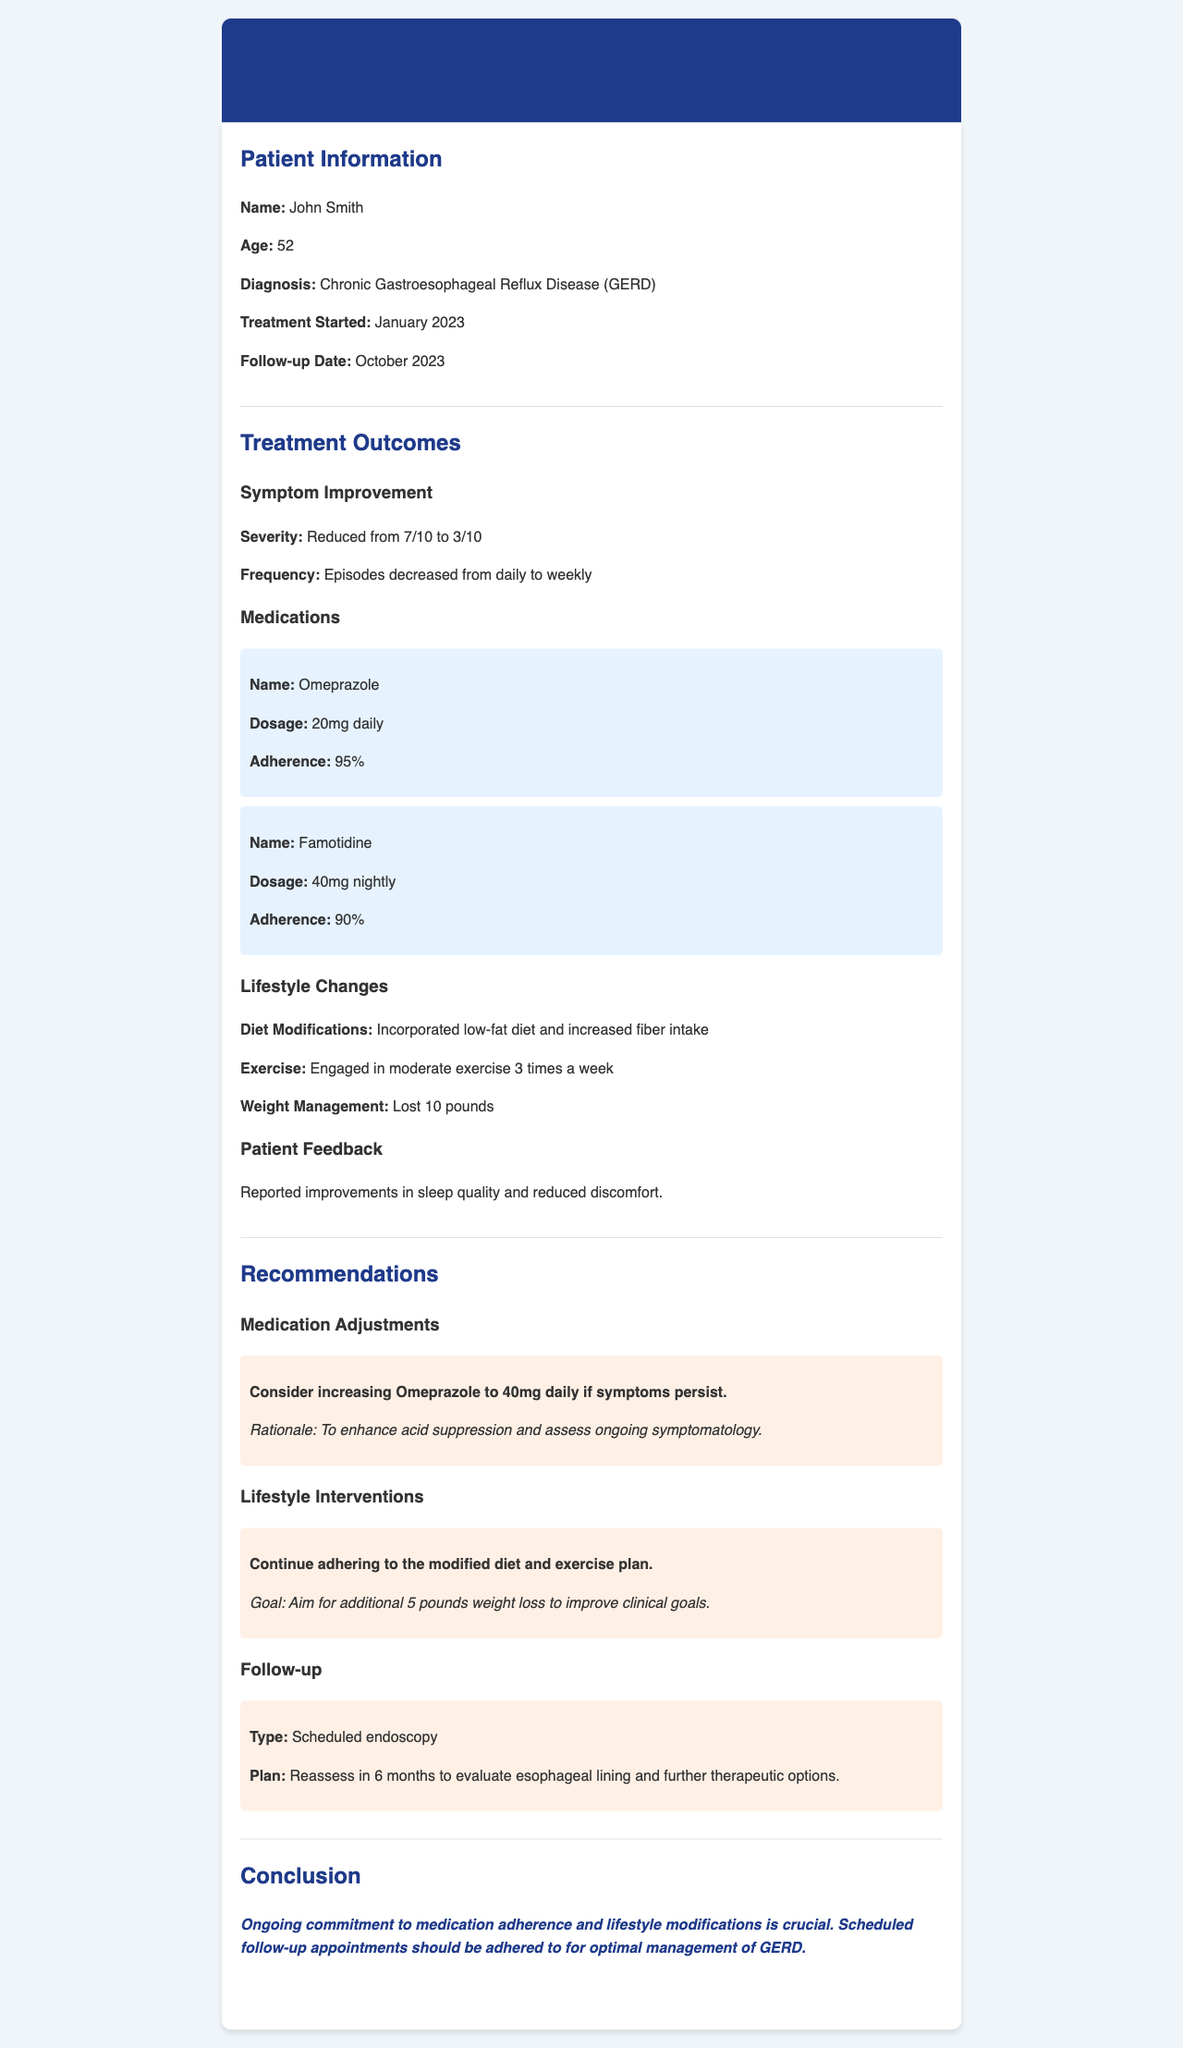What is the patient's name? The patient's name is provided in the Patient Information section of the report.
Answer: John Smith What is the patient's diagnosis? The diagnosis is clearly stated in the Patient Information section.
Answer: Chronic Gastroesophageal Reflux Disease (GERD) What was the patient's symptom severity before treatment? The severity before treatment is mentioned in the Treatment Outcomes section.
Answer: 7/10 What medication is being taken at night? The name of the nightly medication is found in the Treatments Outcomes section under Medications.
Answer: Famotidine What lifestyle change has the patient made regarding weight? The patient's weight management progress is documented in the Treatment Outcomes section.
Answer: Lost 10 pounds What is the recommended dose increase for Omeprazole if symptoms persist? The recommendation for medication adjustment can be found in the Recommendations section.
Answer: 40mg daily How often did the patient engage in exercise? The frequency of exercise is mentioned under Lifestyle Changes in the Treatment Outcomes section.
Answer: 3 times a week What is the goal for weight loss according to the recommendations? The patient's weight loss goal is stated in the Recommendations section under Lifestyle Interventions.
Answer: Additional 5 pounds When is the next follow-up for the patient scheduled? The scheduled follow-up timeframe is indicated in the Recommendations section.
Answer: 6 months 